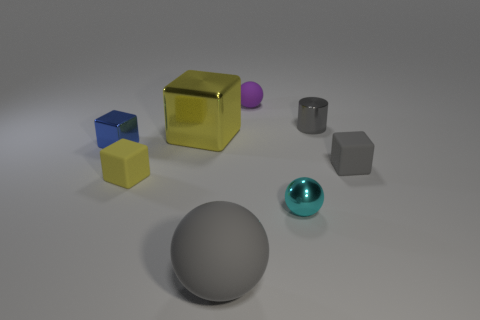Add 2 big blue metallic spheres. How many objects exist? 10 Subtract all spheres. How many objects are left? 5 Add 7 tiny cyan metal things. How many tiny cyan metal things are left? 8 Add 4 tiny purple things. How many tiny purple things exist? 5 Subtract 1 gray cylinders. How many objects are left? 7 Subtract all tiny gray rubber objects. Subtract all brown rubber cylinders. How many objects are left? 7 